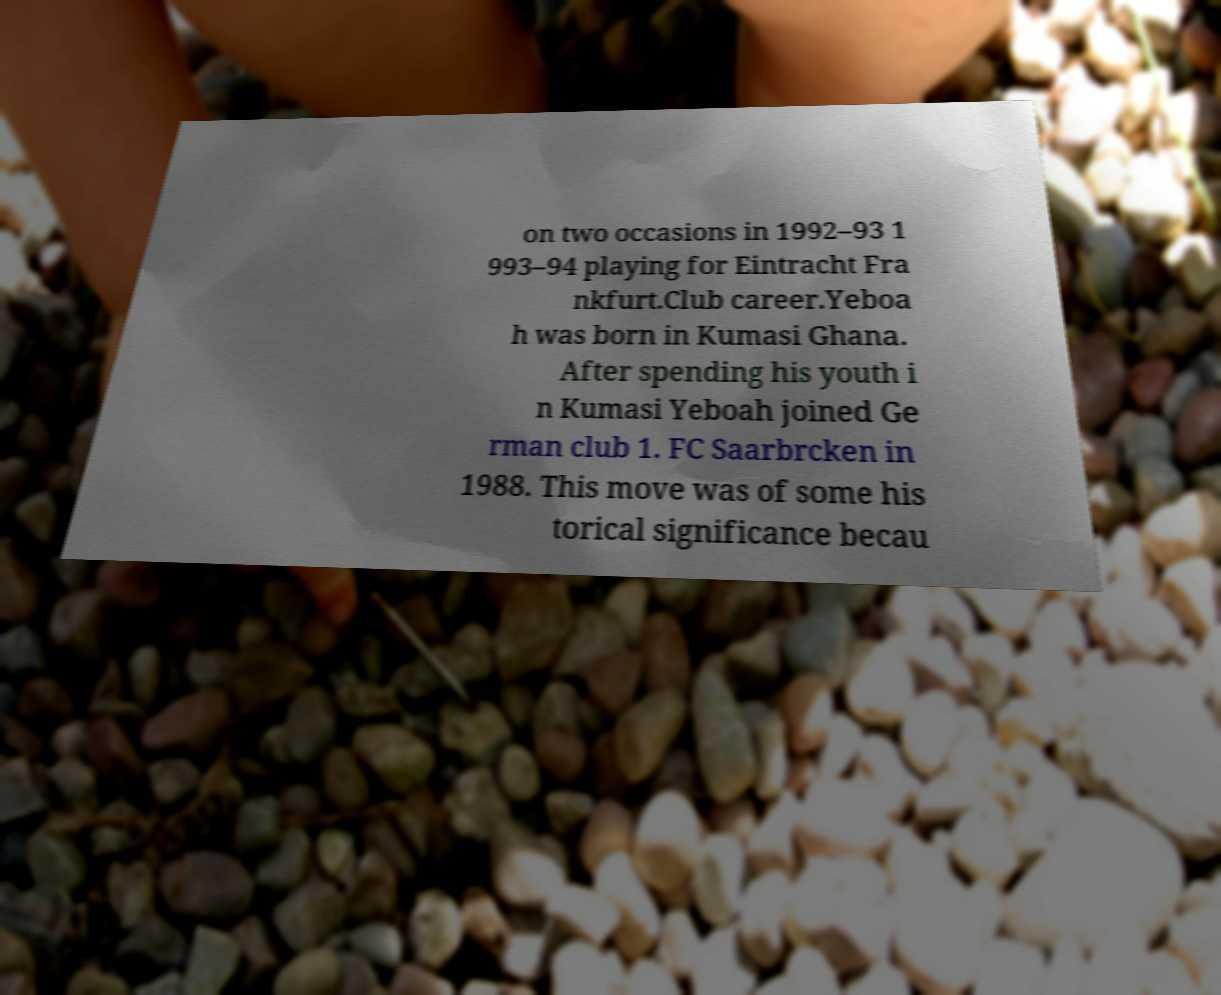Please identify and transcribe the text found in this image. on two occasions in 1992–93 1 993–94 playing for Eintracht Fra nkfurt.Club career.Yeboa h was born in Kumasi Ghana. After spending his youth i n Kumasi Yeboah joined Ge rman club 1. FC Saarbrcken in 1988. This move was of some his torical significance becau 